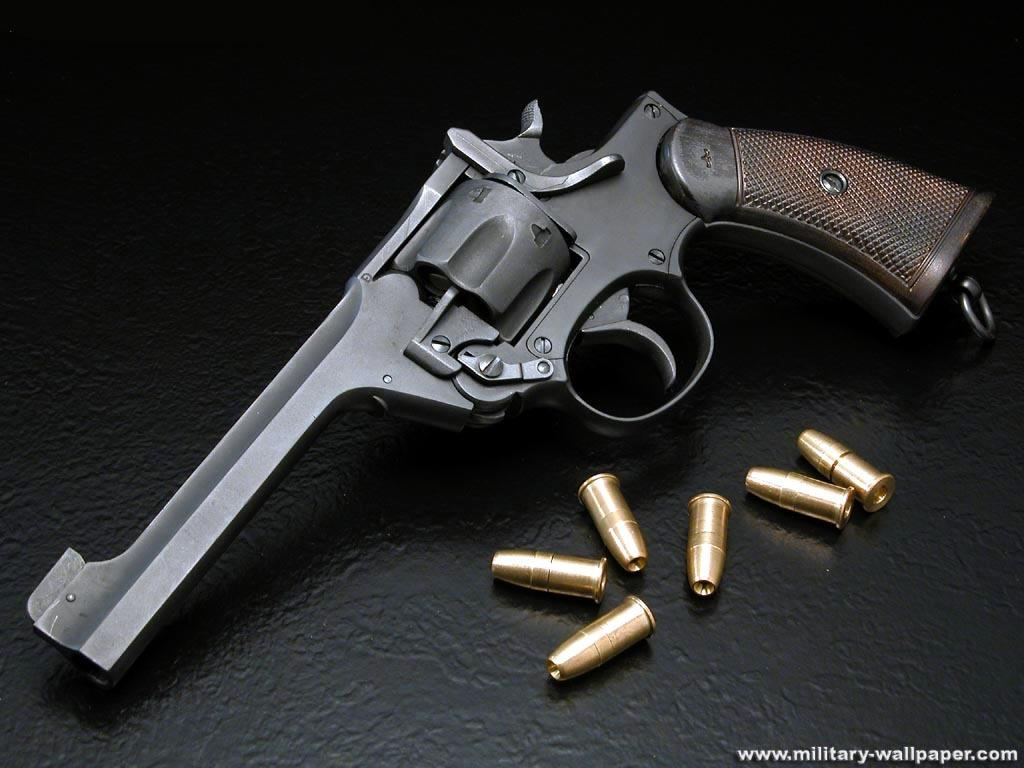What object is the main subject of the image? There is a gun in the image. What else is present with the gun in the image? There are bullets in the image. Where are the gun and bullets located? The gun and bullets are on a table. What can be seen at the bottom of the image? There is text at the bottom of the image. What advice does the gun give in the image? The gun does not give any advice in the image, as it is an inanimate object and cannot speak or provide advice. 